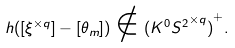Convert formula to latex. <formula><loc_0><loc_0><loc_500><loc_500>h ( [ \xi ^ { \times q } ] - [ \theta _ { m } ] ) \notin { ( K ^ { 0 } { S ^ { 2 } } ^ { \times q } ) } ^ { + } .</formula> 